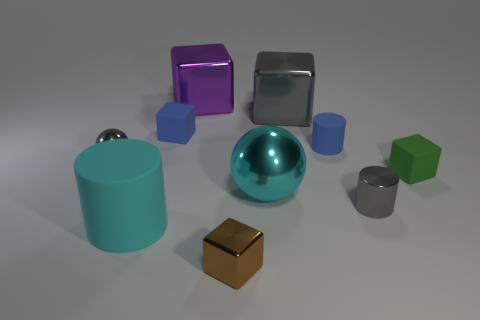Subtract all green blocks. How many blocks are left? 4 Subtract 1 blocks. How many blocks are left? 4 Subtract all big gray cubes. How many cubes are left? 4 Subtract all cyan blocks. Subtract all green spheres. How many blocks are left? 5 Subtract all spheres. How many objects are left? 8 Subtract 0 yellow cylinders. How many objects are left? 10 Subtract all gray objects. Subtract all small cylinders. How many objects are left? 5 Add 7 brown objects. How many brown objects are left? 8 Add 6 cyan shiny blocks. How many cyan shiny blocks exist? 6 